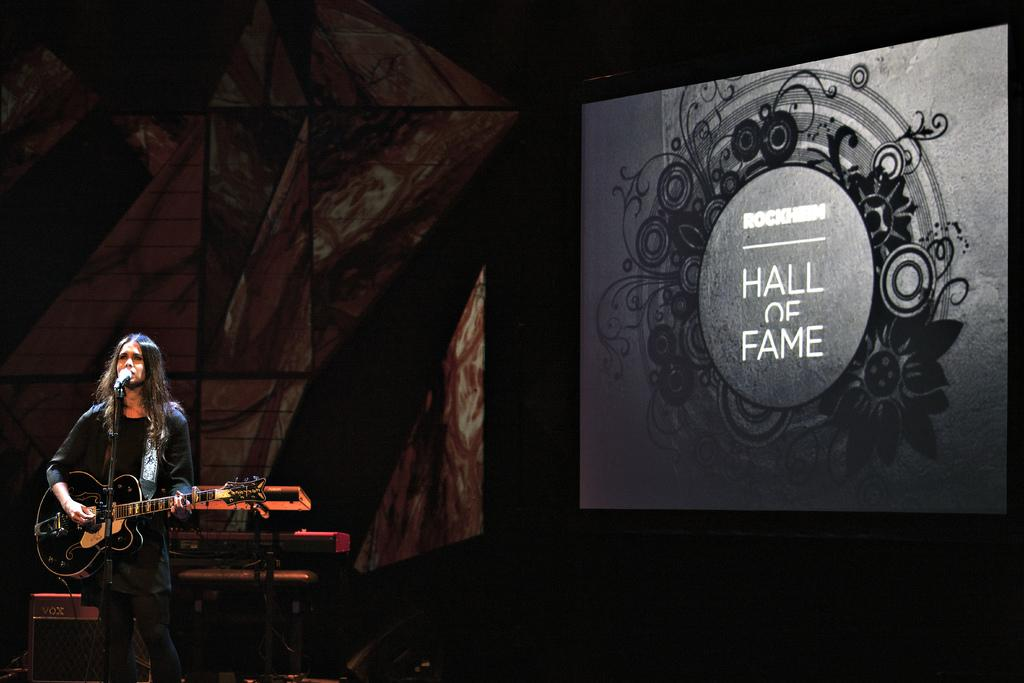Who is the main subject in the image? There is a woman in the image. What is the woman doing in the image? The woman is standing and holding a guitar. What object is in front of the woman? There is a microphone in front of the woman. What can be seen in the background of the image? In the background, there is a screen with "HALL OF FAME" written on it. What type of insect is crawling on the woman's guitar in the image? There is no insect present in the image; the woman is holding a guitar without any insects on it. 